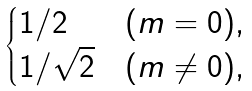<formula> <loc_0><loc_0><loc_500><loc_500>\begin{cases} 1 / 2 & ( m = 0 ) , \\ 1 / \sqrt { 2 } & ( m \neq 0 ) , \\ \end{cases}</formula> 